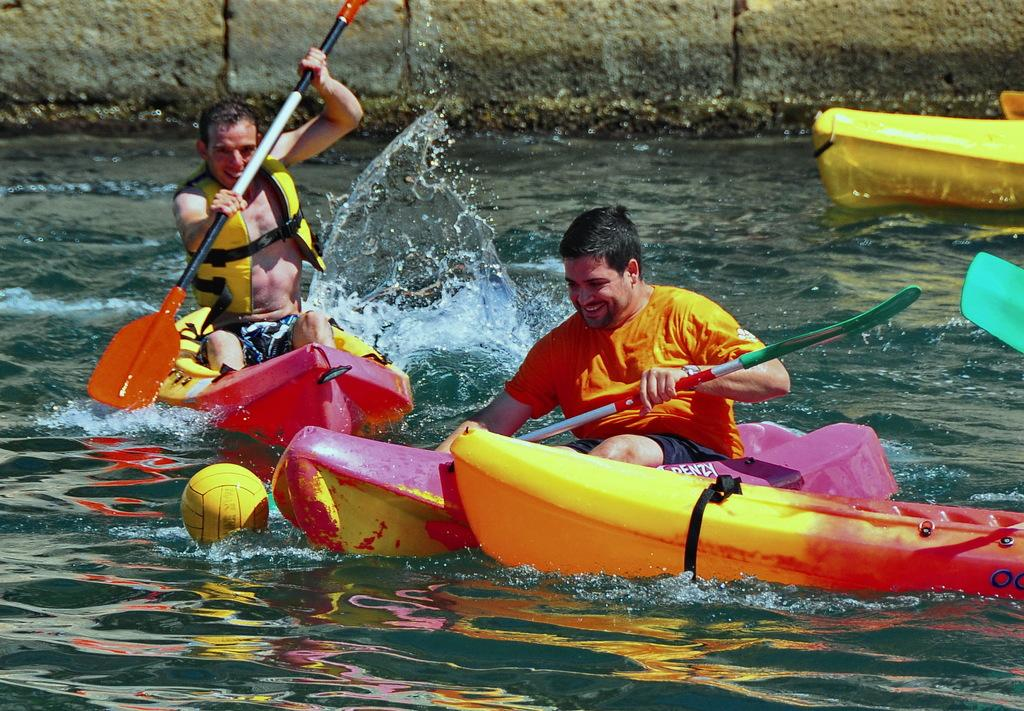What is the main subject in the center of the image? There is water in the center of the image. What is on the water? There are boats on the water. Who is in the boats? People are sitting in the boats. What is located on the left side of the image? There is a ball on the left side of the image. What can be seen in the background of the image? There is a wall in the background of the image. Where is the fireman with the van in the image? There is no fireman or van present in the image. What type of pen is being used by the people in the boats? There is no pen visible in the image; people are sitting in the boats on the water. 